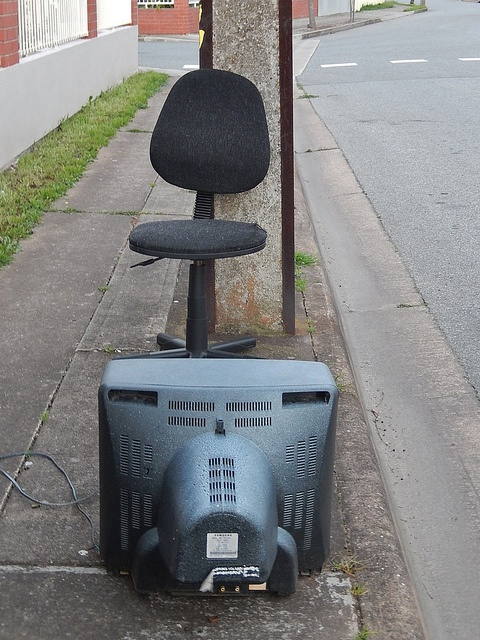Describe the objects in this image and their specific colors. I can see tv in salmon, black, gray, and darkgray tones and chair in salmon, black, and gray tones in this image. 